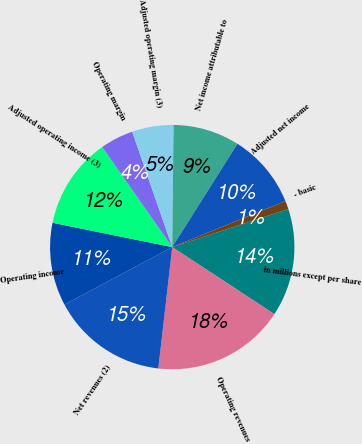<chart> <loc_0><loc_0><loc_500><loc_500><pie_chart><fcel>in millions except per share<fcel>Operating revenues<fcel>Net revenues (2)<fcel>Operating income<fcel>Adjusted operating income (3)<fcel>Operating margin<fcel>Adjusted operating margin (3)<fcel>Net income attributable to<fcel>Adjusted net income<fcel>- basic<nl><fcel>14.29%<fcel>17.58%<fcel>15.38%<fcel>10.99%<fcel>12.09%<fcel>4.4%<fcel>5.49%<fcel>8.79%<fcel>9.89%<fcel>1.1%<nl></chart> 